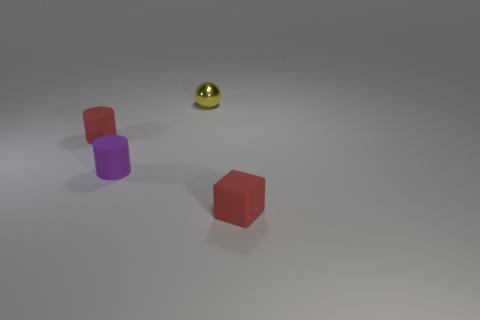Which object in the image appears to be closest to the camera? The red rubber cylinder is the closest object to the camera in this image. Its size relative to the other objects and its clear, focused edges suggest its proximity in comparison to the other items around it. Could you describe the texture that is most prominent in this image? The most prominent texture in the image appears to be the mat finish of the cylinders and the sphere. The surface reflects light in a diffused manner, indicating the objects have a non-glossy, rubber-like texture. 